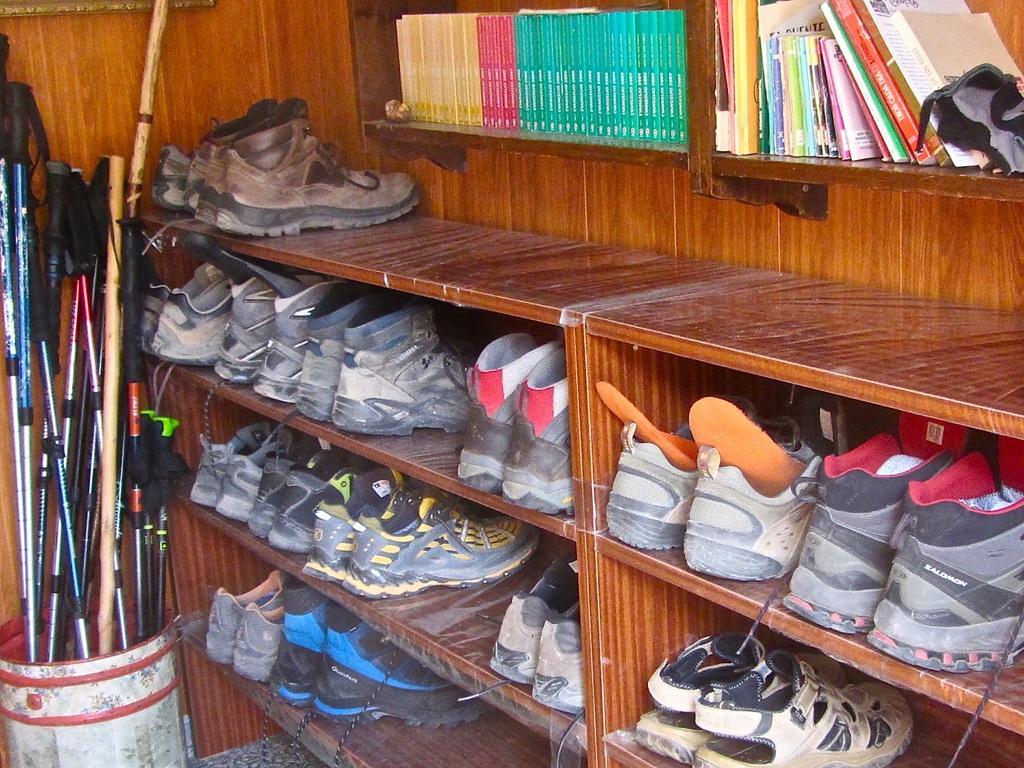Could you give a brief overview of what you see in this image? In this picture we can see some racks, there are some pairs of shoes present on the racks, on the left side there is a bucket, we can see some sticks in the bucket, at the right top there are some books present on this rack. 